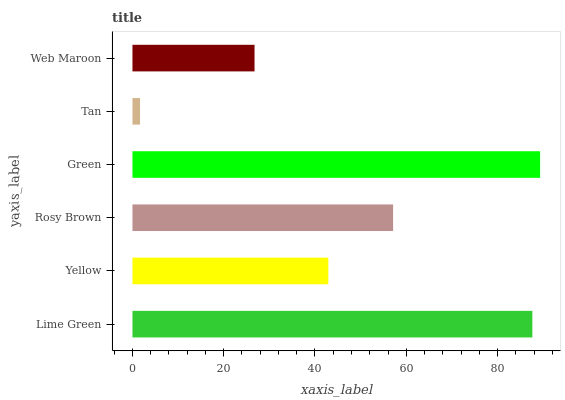Is Tan the minimum?
Answer yes or no. Yes. Is Green the maximum?
Answer yes or no. Yes. Is Yellow the minimum?
Answer yes or no. No. Is Yellow the maximum?
Answer yes or no. No. Is Lime Green greater than Yellow?
Answer yes or no. Yes. Is Yellow less than Lime Green?
Answer yes or no. Yes. Is Yellow greater than Lime Green?
Answer yes or no. No. Is Lime Green less than Yellow?
Answer yes or no. No. Is Rosy Brown the high median?
Answer yes or no. Yes. Is Yellow the low median?
Answer yes or no. Yes. Is Green the high median?
Answer yes or no. No. Is Web Maroon the low median?
Answer yes or no. No. 